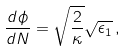<formula> <loc_0><loc_0><loc_500><loc_500>\frac { d \phi } { d N } = \sqrt { \frac { 2 } { \kappa } } \sqrt { \epsilon _ { 1 } } \, ,</formula> 